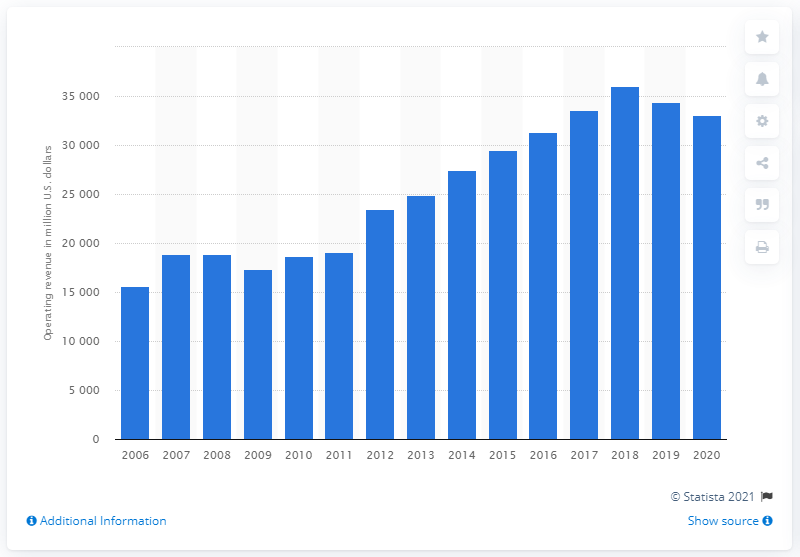Point out several critical features in this image. Exelon Corporation's operating revenue in 2020 was approximately $330,390. Exelon Corporation's operating revenue in 2018 was 35,978. 